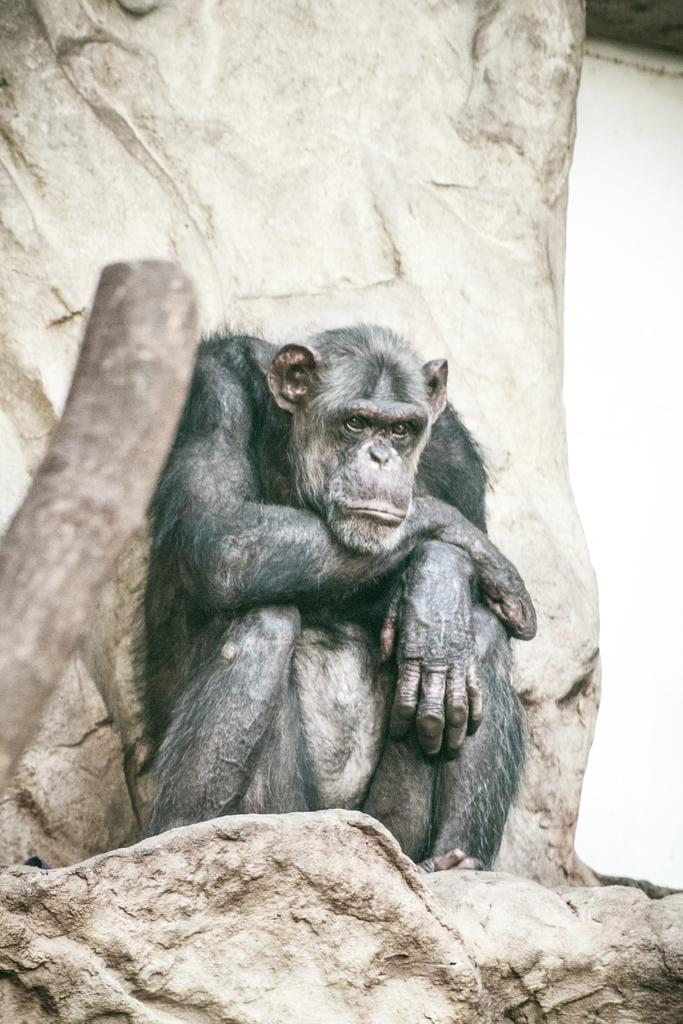What animal is in the image? There is a chimpanzee in the image. What is the chimpanzee doing in the image? The chimpanzee is sitting on a rock. What type of power source can be seen in the image? There is no power source visible in the image; it features a chimpanzee sitting on a rock. How many turkeys are present in the image? There are no turkeys present in the image; it features a chimpanzee sitting on a rock. 